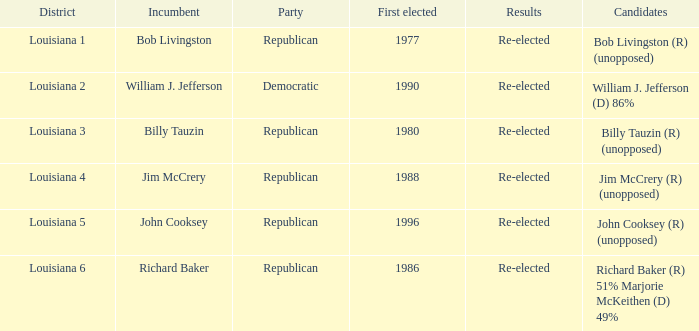What party does William J. Jefferson? Democratic. 